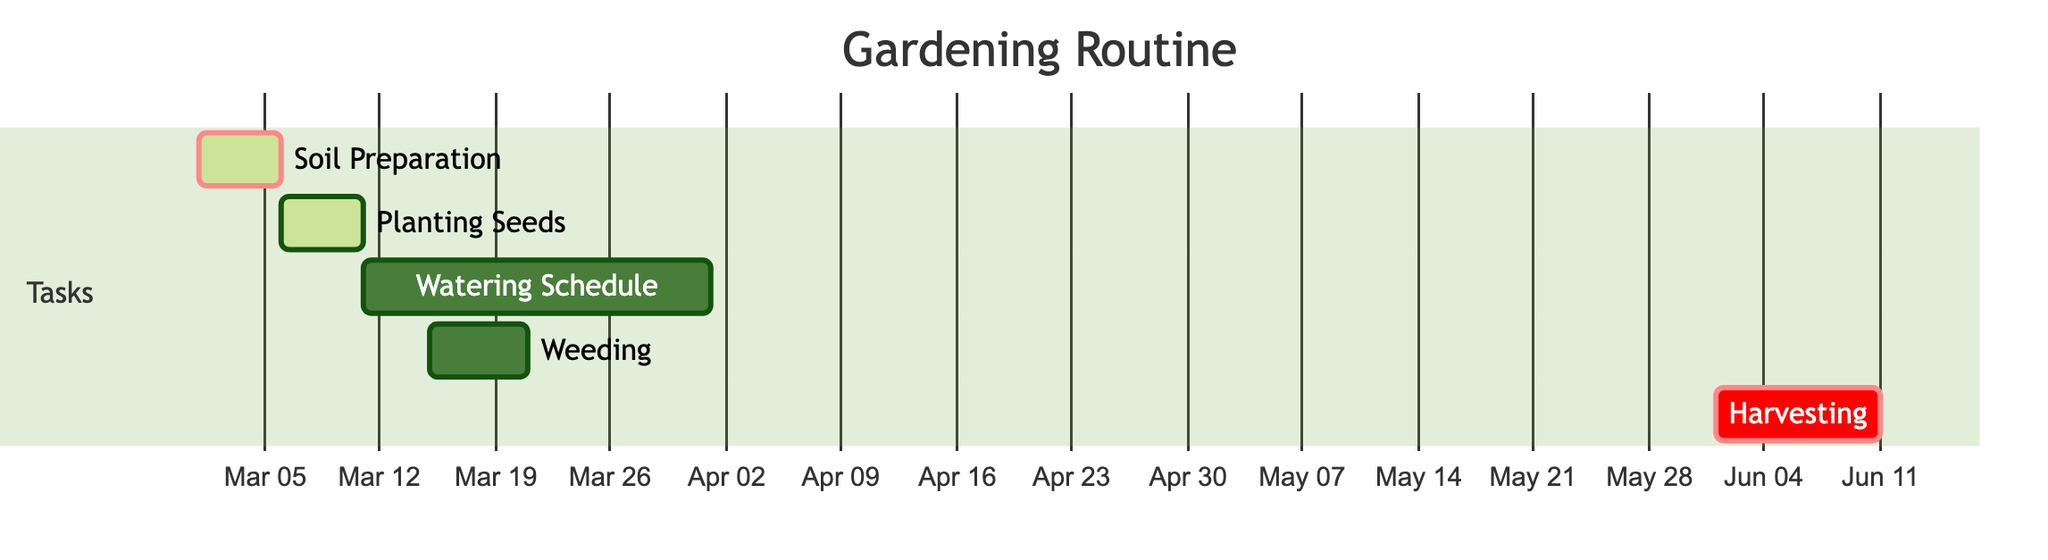What is the duration of Soil Preparation? The task "Soil Preparation" starts on March 1, 2023, and ends on March 5, 2023. The duration is calculated as the end date minus the start date, which gives us 5 days.
Answer: 5 days When does the Watering Schedule start? The "Watering Schedule" begins on March 11, 2023, as indicated by the start date assigned to this task in the diagram.
Answer: March 11, 2023 What task overlaps with Weeding? The "Weeding" task starts on March 15, 2023, and ends on March 20, 2023. The "Watering Schedule" covers March 11 to March 31, which means they overlap from March 15 to March 20.
Answer: Watering Schedule How many tasks are planned from March 1 to March 10? The tasks scheduled during this period include "Soil Preparation" (March 1 - March 5) and "Planting Seeds" (March 6 - March 10). Therefore, there are 2 tasks planned in this timeframe.
Answer: 2 tasks Which task has the longest duration? Among the listed tasks, "Watering Schedule" lasts from March 11 to March 31, which is a total of 21 days. This is longer than the other tasks, which have shorter durations.
Answer: Watering Schedule What is the total number of tasks in the Gardening Routine? The Gantt chart lists 5 tasks: Soil Preparation, Planting Seeds, Watering Schedule, Weeding, and Harvesting. Counting these gives us a total of 5 tasks.
Answer: 5 tasks Which task is critical according to the diagram? The tasks labeled as critical include "Soil Preparation" and "Harvesting." These are marked with the keyword "crit" in the code, indicating their importance.
Answer: Soil Preparation, Harvesting What is the end date of Harvesting? According to the tasks listed in the diagram, the end date for the "Harvesting" task is June 10, 2023.
Answer: June 10, 2023 